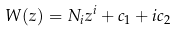Convert formula to latex. <formula><loc_0><loc_0><loc_500><loc_500>W ( z ) = N _ { i } z ^ { i } + c _ { 1 } + i c _ { 2 }</formula> 